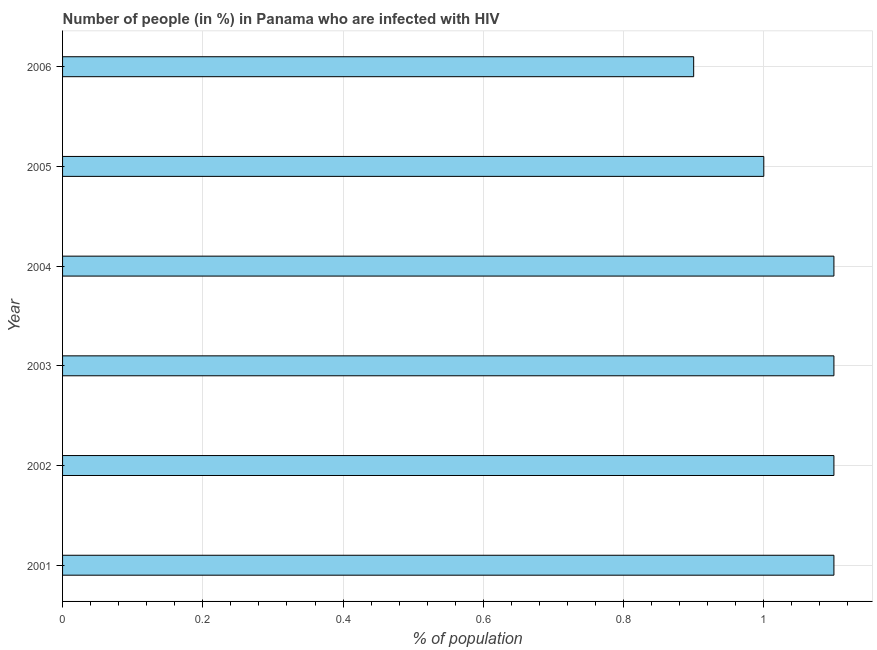Does the graph contain any zero values?
Ensure brevity in your answer.  No. What is the title of the graph?
Your answer should be compact. Number of people (in %) in Panama who are infected with HIV. What is the label or title of the X-axis?
Your response must be concise. % of population. Across all years, what is the maximum number of people infected with hiv?
Provide a succinct answer. 1.1. Across all years, what is the minimum number of people infected with hiv?
Your response must be concise. 0.9. In which year was the number of people infected with hiv maximum?
Your response must be concise. 2001. In which year was the number of people infected with hiv minimum?
Your response must be concise. 2006. What is the sum of the number of people infected with hiv?
Ensure brevity in your answer.  6.3. What is the average number of people infected with hiv per year?
Give a very brief answer. 1.05. What is the median number of people infected with hiv?
Give a very brief answer. 1.1. What is the ratio of the number of people infected with hiv in 2002 to that in 2006?
Offer a very short reply. 1.22. What is the difference between the highest and the second highest number of people infected with hiv?
Provide a succinct answer. 0. Is the sum of the number of people infected with hiv in 2005 and 2006 greater than the maximum number of people infected with hiv across all years?
Your answer should be compact. Yes. What is the difference between the highest and the lowest number of people infected with hiv?
Your answer should be compact. 0.2. In how many years, is the number of people infected with hiv greater than the average number of people infected with hiv taken over all years?
Provide a short and direct response. 4. How many bars are there?
Your answer should be very brief. 6. Are the values on the major ticks of X-axis written in scientific E-notation?
Offer a terse response. No. What is the % of population in 2002?
Offer a very short reply. 1.1. What is the % of population of 2005?
Your response must be concise. 1. What is the difference between the % of population in 2001 and 2003?
Your response must be concise. 0. What is the difference between the % of population in 2001 and 2004?
Give a very brief answer. 0. What is the difference between the % of population in 2001 and 2005?
Your answer should be very brief. 0.1. What is the difference between the % of population in 2001 and 2006?
Make the answer very short. 0.2. What is the difference between the % of population in 2002 and 2003?
Your answer should be compact. 0. What is the difference between the % of population in 2002 and 2004?
Your answer should be very brief. 0. What is the difference between the % of population in 2002 and 2005?
Offer a very short reply. 0.1. What is the difference between the % of population in 2002 and 2006?
Provide a succinct answer. 0.2. What is the difference between the % of population in 2003 and 2005?
Make the answer very short. 0.1. What is the ratio of the % of population in 2001 to that in 2002?
Offer a very short reply. 1. What is the ratio of the % of population in 2001 to that in 2006?
Your answer should be compact. 1.22. What is the ratio of the % of population in 2002 to that in 2003?
Your response must be concise. 1. What is the ratio of the % of population in 2002 to that in 2004?
Your response must be concise. 1. What is the ratio of the % of population in 2002 to that in 2006?
Provide a short and direct response. 1.22. What is the ratio of the % of population in 2003 to that in 2005?
Offer a terse response. 1.1. What is the ratio of the % of population in 2003 to that in 2006?
Keep it short and to the point. 1.22. What is the ratio of the % of population in 2004 to that in 2005?
Your answer should be very brief. 1.1. What is the ratio of the % of population in 2004 to that in 2006?
Give a very brief answer. 1.22. What is the ratio of the % of population in 2005 to that in 2006?
Ensure brevity in your answer.  1.11. 